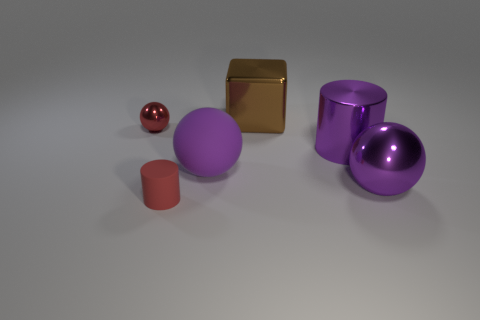How many large things are rubber spheres or red objects?
Your answer should be compact. 1. What shape is the brown object?
Provide a succinct answer. Cube. There is a metallic cylinder that is the same color as the large matte object; what size is it?
Your answer should be very brief. Large. Is there a large purple object made of the same material as the tiny cylinder?
Your answer should be compact. Yes. Is the number of large purple objects greater than the number of small metallic objects?
Keep it short and to the point. Yes. Does the small cylinder have the same material as the large block?
Ensure brevity in your answer.  No. What number of rubber objects are tiny red objects or cyan cubes?
Keep it short and to the point. 1. There is a metallic cylinder that is the same size as the matte ball; what color is it?
Your answer should be compact. Purple. How many red matte objects have the same shape as the red metal object?
Give a very brief answer. 0. What number of cylinders are either tiny red metal things or large metallic objects?
Make the answer very short. 1. 